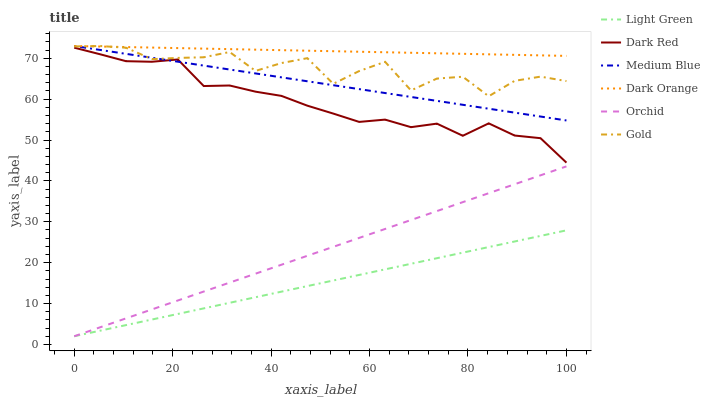Does Gold have the minimum area under the curve?
Answer yes or no. No. Does Gold have the maximum area under the curve?
Answer yes or no. No. Is Dark Red the smoothest?
Answer yes or no. No. Is Dark Red the roughest?
Answer yes or no. No. Does Gold have the lowest value?
Answer yes or no. No. Does Dark Red have the highest value?
Answer yes or no. No. Is Light Green less than Medium Blue?
Answer yes or no. Yes. Is Gold greater than Orchid?
Answer yes or no. Yes. Does Light Green intersect Medium Blue?
Answer yes or no. No. 